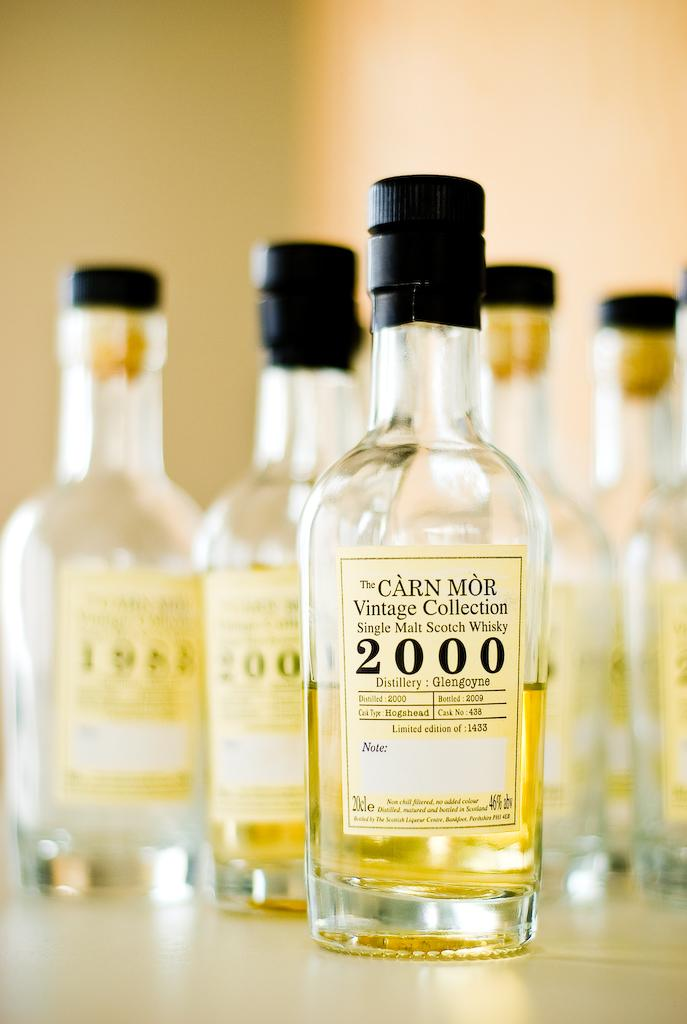<image>
Offer a succinct explanation of the picture presented. Bottles of single malt scotch whiskey from the Carn Mor Vintage Collection. 